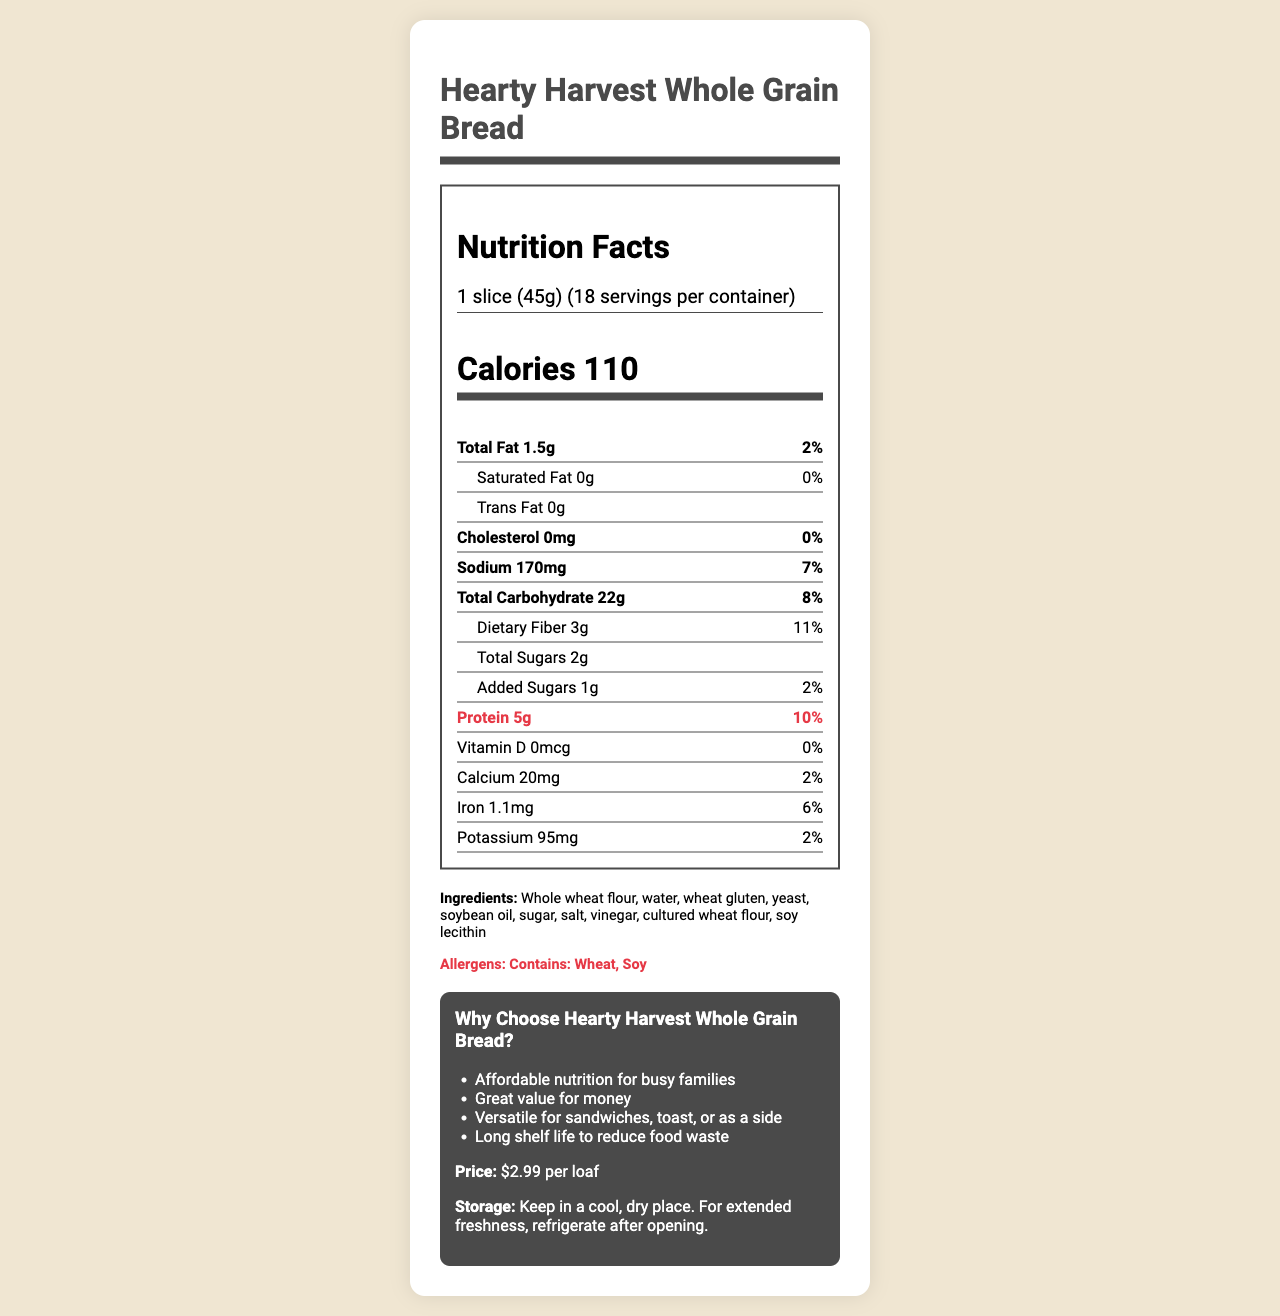what is the serving size of Hearty Harvest Whole Grain Bread? The serving size is listed as "1 slice (45g)" in the nutrition facts section.
Answer: 1 slice (45g) how many calories are in one serving? The document states that there are 110 calories per serving.
Answer: 110 what is the total carbohydrate content per serving? The total carbohydrate content per serving is provided in the nutrition facts as 22g.
Answer: 22g what percentage of the daily value does the sodium content represent? The sodium content is 170mg, which represents 7% of the daily value.
Answer: 7% is there any trans fat in Hearty Harvest Whole Grain Bread? Trans fat content is listed as "0g," indicating there is no trans fat.
Answer: No how much protein does one slice provide? The protein content per serving is highlighted as 5g in the nutrition facts.
Answer: 5g which of the following ingredients are allergens in this bread? A. Wheat B. Soy C. Milk D. Peanuts The allergens listed are Wheat and Soy.
Answer: A, B how many servings are there per container? A. 10 B. 12 C. 18 D. 20 The document states that there are 18 servings per container.
Answer: C how much iron is in one serving? A. 1.1mg B. 2.2mg C. 3.3mg D. 0.5mg The iron content is listed as 1.1mg per serving.
Answer: A does this bread contain any added sugars? The document shows that there is 1g of added sugars.
Answer: Yes can this bread be stored in a refrigerator? The storage instructions state that for extended freshness, the bread should be refrigerated after opening.
Answer: Yes what are the health highlights of this bread? The highlights listed in the document include these health benefits.
Answer: Good source of protein, High in fiber, No artificial preservatives, Made with 100% whole grains which nutrients have 0% daily value in this bread? These nutrients have a daily value of 0% according to the nutrition facts.
Answer: Saturated Fat, Trans Fat, Cholesterol, Vitamin D what is the main idea of this document? The document provides comprehensive information about the bread, including nutritional content, health benefits, ingredients, storage, and appeal to working-class families.
Answer: This document is a detailed nutrition facts label for Hearty Harvest Whole Grain Bread by Budget Bakers Co., highlighting its health benefits, ingredients, and allergen information, along with storage instructions and price. what is the price of Hearty Harvest Whole Grain Bread? The price is given as $2.99 per loaf under the working-class appeal section.
Answer: $2.99 per loaf how many grams of dietary fiber does each serving contain? The dietary fiber content is specified as 3g per serving.
Answer: 3g where is the bread manufactured? The manufacturer is listed as "Budget Bakers Co." but the location is not provided in the document.
Answer: Cannot be determined 